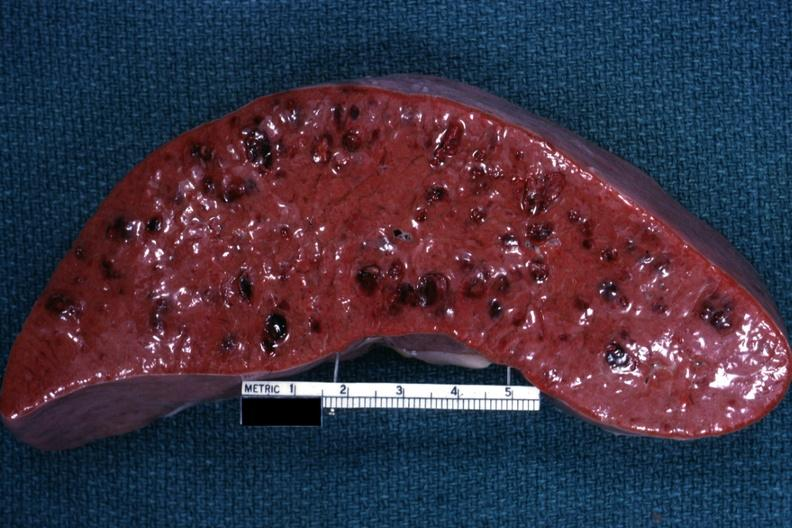s yellow color present?
Answer the question using a single word or phrase. No 